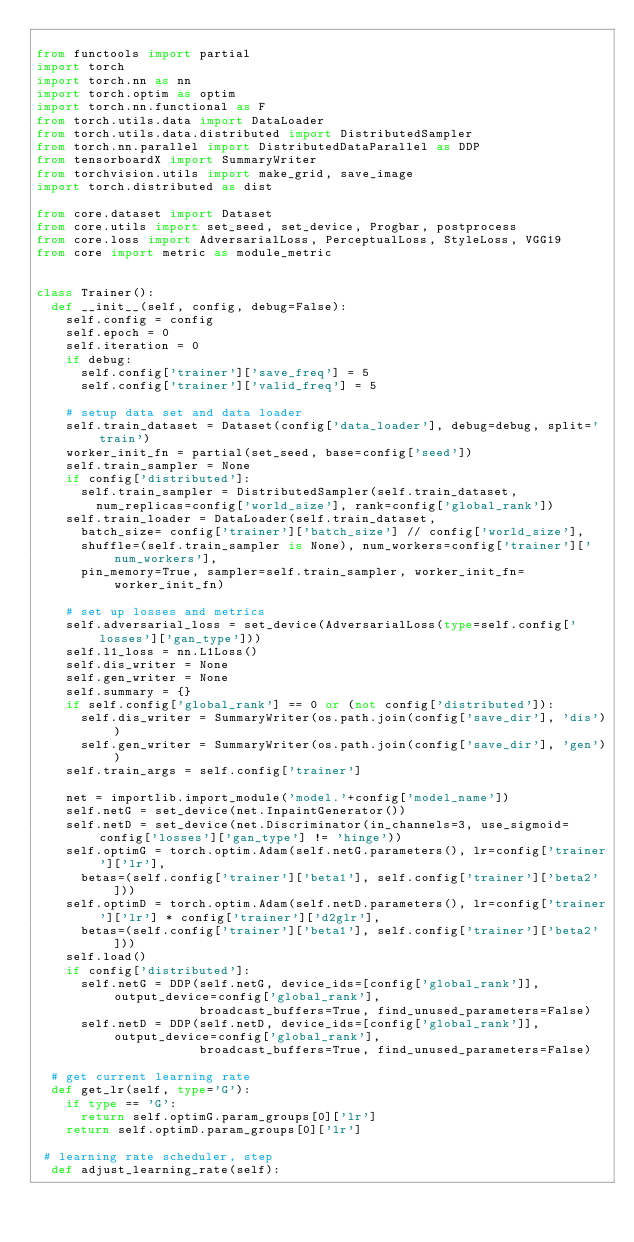<code> <loc_0><loc_0><loc_500><loc_500><_Python_>
from functools import partial
import torch
import torch.nn as nn
import torch.optim as optim
import torch.nn.functional as F
from torch.utils.data import DataLoader
from torch.utils.data.distributed import DistributedSampler
from torch.nn.parallel import DistributedDataParallel as DDP
from tensorboardX import SummaryWriter
from torchvision.utils import make_grid, save_image
import torch.distributed as dist

from core.dataset import Dataset
from core.utils import set_seed, set_device, Progbar, postprocess
from core.loss import AdversarialLoss, PerceptualLoss, StyleLoss, VGG19
from core import metric as module_metric


class Trainer():
  def __init__(self, config, debug=False):
    self.config = config
    self.epoch = 0
    self.iteration = 0
    if debug:
      self.config['trainer']['save_freq'] = 5
      self.config['trainer']['valid_freq'] = 5

    # setup data set and data loader
    self.train_dataset = Dataset(config['data_loader'], debug=debug, split='train')
    worker_init_fn = partial(set_seed, base=config['seed'])
    self.train_sampler = None
    if config['distributed']:
      self.train_sampler = DistributedSampler(self.train_dataset, 
        num_replicas=config['world_size'], rank=config['global_rank'])
    self.train_loader = DataLoader(self.train_dataset, 
      batch_size= config['trainer']['batch_size'] // config['world_size'],
      shuffle=(self.train_sampler is None), num_workers=config['trainer']['num_workers'],
      pin_memory=True, sampler=self.train_sampler, worker_init_fn=worker_init_fn)

    # set up losses and metrics
    self.adversarial_loss = set_device(AdversarialLoss(type=self.config['losses']['gan_type']))
    self.l1_loss = nn.L1Loss()
    self.dis_writer = None
    self.gen_writer = None
    self.summary = {}
    if self.config['global_rank'] == 0 or (not config['distributed']):
      self.dis_writer = SummaryWriter(os.path.join(config['save_dir'], 'dis'))
      self.gen_writer = SummaryWriter(os.path.join(config['save_dir'], 'gen'))
    self.train_args = self.config['trainer']

    net = importlib.import_module('model.'+config['model_name'])
    self.netG = set_device(net.InpaintGenerator())
    self.netD = set_device(net.Discriminator(in_channels=3, use_sigmoid=config['losses']['gan_type'] != 'hinge'))
    self.optimG = torch.optim.Adam(self.netG.parameters(), lr=config['trainer']['lr'],
      betas=(self.config['trainer']['beta1'], self.config['trainer']['beta2']))
    self.optimD = torch.optim.Adam(self.netD.parameters(), lr=config['trainer']['lr'] * config['trainer']['d2glr'],
      betas=(self.config['trainer']['beta1'], self.config['trainer']['beta2']))
    self.load()
    if config['distributed']:
      self.netG = DDP(self.netG, device_ids=[config['global_rank']], output_device=config['global_rank'], 
                      broadcast_buffers=True, find_unused_parameters=False)
      self.netD = DDP(self.netD, device_ids=[config['global_rank']], output_device=config['global_rank'], 
                      broadcast_buffers=True, find_unused_parameters=False)

  # get current learning rate
  def get_lr(self, type='G'):
    if type == 'G':
      return self.optimG.param_groups[0]['lr']
    return self.optimD.param_groups[0]['lr']
  
 # learning rate scheduler, step
  def adjust_learning_rate(self):</code> 